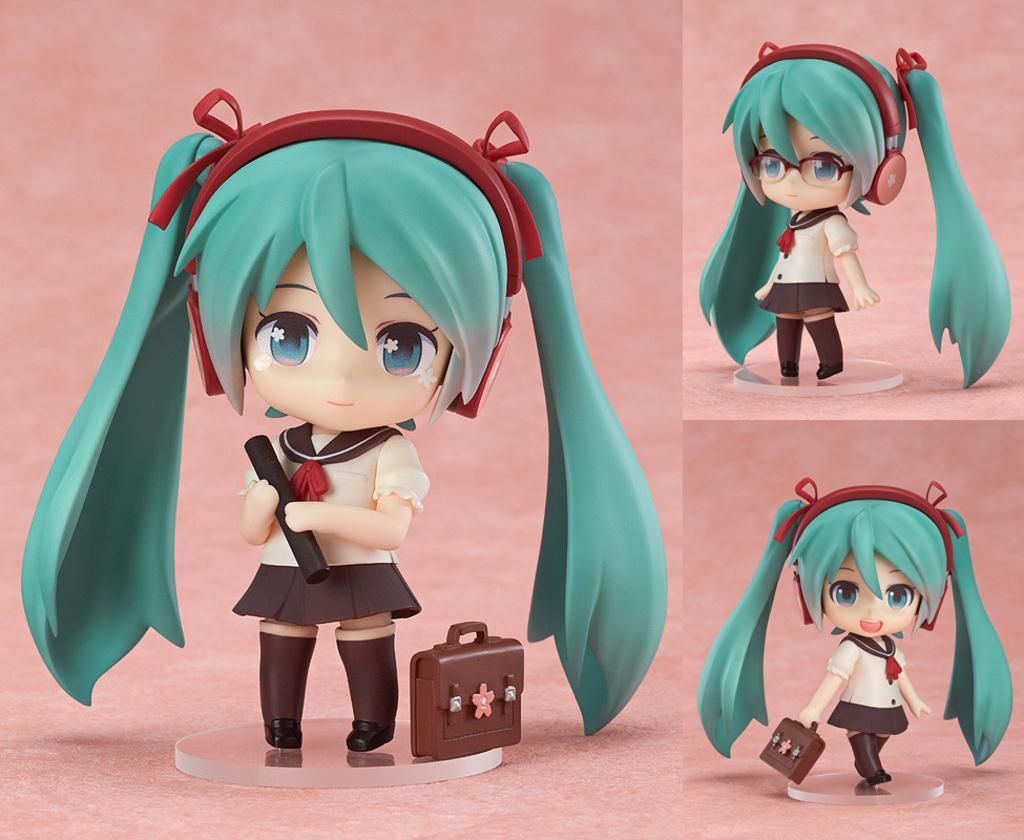Describe this image in one or two sentences. This is an animated image where we can see a doll in the three images with blue color hair and headphones, here we can see a briefcase. The background of the image is pink in color. 